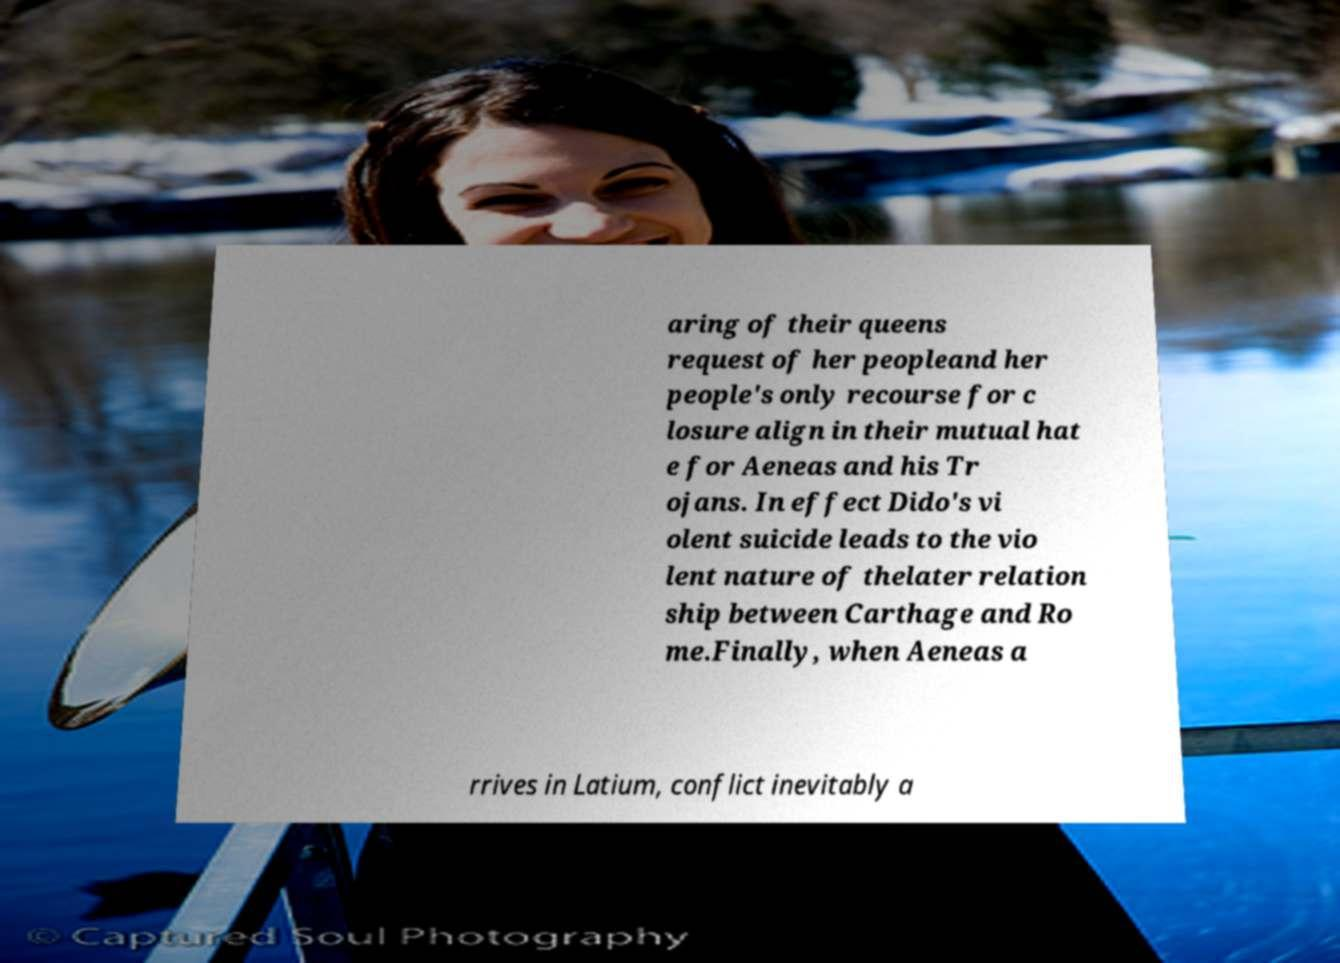Could you extract and type out the text from this image? aring of their queens request of her peopleand her people's only recourse for c losure align in their mutual hat e for Aeneas and his Tr ojans. In effect Dido's vi olent suicide leads to the vio lent nature of thelater relation ship between Carthage and Ro me.Finally, when Aeneas a rrives in Latium, conflict inevitably a 